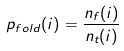<formula> <loc_0><loc_0><loc_500><loc_500>p _ { f o l d } ( i ) = \frac { n _ { f } ( i ) } { n _ { t } ( i ) } \</formula> 